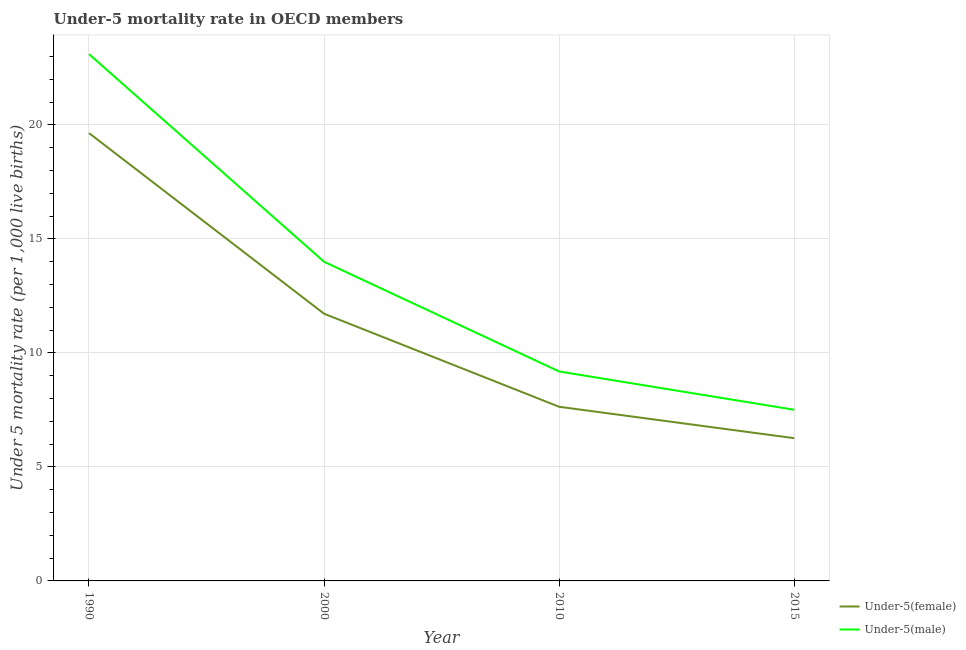Does the line corresponding to under-5 male mortality rate intersect with the line corresponding to under-5 female mortality rate?
Your response must be concise. No. What is the under-5 male mortality rate in 2010?
Your response must be concise. 9.19. Across all years, what is the maximum under-5 male mortality rate?
Ensure brevity in your answer.  23.11. Across all years, what is the minimum under-5 male mortality rate?
Give a very brief answer. 7.51. In which year was the under-5 female mortality rate maximum?
Keep it short and to the point. 1990. In which year was the under-5 male mortality rate minimum?
Your response must be concise. 2015. What is the total under-5 female mortality rate in the graph?
Provide a short and direct response. 45.26. What is the difference between the under-5 female mortality rate in 1990 and that in 2015?
Make the answer very short. 13.38. What is the difference between the under-5 male mortality rate in 2015 and the under-5 female mortality rate in 2010?
Ensure brevity in your answer.  -0.13. What is the average under-5 female mortality rate per year?
Give a very brief answer. 11.32. In the year 2010, what is the difference between the under-5 male mortality rate and under-5 female mortality rate?
Provide a succinct answer. 1.55. In how many years, is the under-5 male mortality rate greater than 7?
Provide a succinct answer. 4. What is the ratio of the under-5 male mortality rate in 2010 to that in 2015?
Keep it short and to the point. 1.22. Is the under-5 male mortality rate in 1990 less than that in 2000?
Provide a short and direct response. No. What is the difference between the highest and the second highest under-5 male mortality rate?
Give a very brief answer. 9.11. What is the difference between the highest and the lowest under-5 male mortality rate?
Offer a terse response. 15.6. Is the sum of the under-5 male mortality rate in 2010 and 2015 greater than the maximum under-5 female mortality rate across all years?
Offer a very short reply. No. Is the under-5 female mortality rate strictly less than the under-5 male mortality rate over the years?
Your response must be concise. Yes. How many lines are there?
Give a very brief answer. 2. Are the values on the major ticks of Y-axis written in scientific E-notation?
Keep it short and to the point. No. Does the graph contain any zero values?
Offer a terse response. No. Does the graph contain grids?
Offer a very short reply. Yes. How many legend labels are there?
Provide a succinct answer. 2. What is the title of the graph?
Provide a short and direct response. Under-5 mortality rate in OECD members. What is the label or title of the Y-axis?
Your answer should be very brief. Under 5 mortality rate (per 1,0 live births). What is the Under 5 mortality rate (per 1,000 live births) in Under-5(female) in 1990?
Your answer should be compact. 19.64. What is the Under 5 mortality rate (per 1,000 live births) of Under-5(male) in 1990?
Make the answer very short. 23.11. What is the Under 5 mortality rate (per 1,000 live births) in Under-5(female) in 2000?
Your response must be concise. 11.72. What is the Under 5 mortality rate (per 1,000 live births) in Under-5(male) in 2000?
Keep it short and to the point. 14. What is the Under 5 mortality rate (per 1,000 live births) of Under-5(female) in 2010?
Make the answer very short. 7.64. What is the Under 5 mortality rate (per 1,000 live births) of Under-5(male) in 2010?
Provide a short and direct response. 9.19. What is the Under 5 mortality rate (per 1,000 live births) of Under-5(female) in 2015?
Make the answer very short. 6.26. What is the Under 5 mortality rate (per 1,000 live births) in Under-5(male) in 2015?
Your response must be concise. 7.51. Across all years, what is the maximum Under 5 mortality rate (per 1,000 live births) of Under-5(female)?
Offer a terse response. 19.64. Across all years, what is the maximum Under 5 mortality rate (per 1,000 live births) of Under-5(male)?
Your answer should be very brief. 23.11. Across all years, what is the minimum Under 5 mortality rate (per 1,000 live births) in Under-5(female)?
Give a very brief answer. 6.26. Across all years, what is the minimum Under 5 mortality rate (per 1,000 live births) of Under-5(male)?
Your answer should be very brief. 7.51. What is the total Under 5 mortality rate (per 1,000 live births) of Under-5(female) in the graph?
Give a very brief answer. 45.26. What is the total Under 5 mortality rate (per 1,000 live births) of Under-5(male) in the graph?
Make the answer very short. 53.8. What is the difference between the Under 5 mortality rate (per 1,000 live births) of Under-5(female) in 1990 and that in 2000?
Give a very brief answer. 7.92. What is the difference between the Under 5 mortality rate (per 1,000 live births) of Under-5(male) in 1990 and that in 2000?
Give a very brief answer. 9.11. What is the difference between the Under 5 mortality rate (per 1,000 live births) of Under-5(female) in 1990 and that in 2010?
Ensure brevity in your answer.  12.01. What is the difference between the Under 5 mortality rate (per 1,000 live births) of Under-5(male) in 1990 and that in 2010?
Provide a succinct answer. 13.92. What is the difference between the Under 5 mortality rate (per 1,000 live births) of Under-5(female) in 1990 and that in 2015?
Make the answer very short. 13.38. What is the difference between the Under 5 mortality rate (per 1,000 live births) of Under-5(male) in 1990 and that in 2015?
Offer a very short reply. 15.6. What is the difference between the Under 5 mortality rate (per 1,000 live births) of Under-5(female) in 2000 and that in 2010?
Offer a terse response. 4.08. What is the difference between the Under 5 mortality rate (per 1,000 live births) in Under-5(male) in 2000 and that in 2010?
Give a very brief answer. 4.81. What is the difference between the Under 5 mortality rate (per 1,000 live births) of Under-5(female) in 2000 and that in 2015?
Ensure brevity in your answer.  5.46. What is the difference between the Under 5 mortality rate (per 1,000 live births) of Under-5(male) in 2000 and that in 2015?
Provide a short and direct response. 6.49. What is the difference between the Under 5 mortality rate (per 1,000 live births) in Under-5(female) in 2010 and that in 2015?
Your answer should be compact. 1.38. What is the difference between the Under 5 mortality rate (per 1,000 live births) of Under-5(male) in 2010 and that in 2015?
Your answer should be very brief. 1.68. What is the difference between the Under 5 mortality rate (per 1,000 live births) in Under-5(female) in 1990 and the Under 5 mortality rate (per 1,000 live births) in Under-5(male) in 2000?
Keep it short and to the point. 5.65. What is the difference between the Under 5 mortality rate (per 1,000 live births) of Under-5(female) in 1990 and the Under 5 mortality rate (per 1,000 live births) of Under-5(male) in 2010?
Make the answer very short. 10.46. What is the difference between the Under 5 mortality rate (per 1,000 live births) of Under-5(female) in 1990 and the Under 5 mortality rate (per 1,000 live births) of Under-5(male) in 2015?
Provide a succinct answer. 12.14. What is the difference between the Under 5 mortality rate (per 1,000 live births) in Under-5(female) in 2000 and the Under 5 mortality rate (per 1,000 live births) in Under-5(male) in 2010?
Keep it short and to the point. 2.53. What is the difference between the Under 5 mortality rate (per 1,000 live births) in Under-5(female) in 2000 and the Under 5 mortality rate (per 1,000 live births) in Under-5(male) in 2015?
Your response must be concise. 4.21. What is the difference between the Under 5 mortality rate (per 1,000 live births) in Under-5(female) in 2010 and the Under 5 mortality rate (per 1,000 live births) in Under-5(male) in 2015?
Your answer should be very brief. 0.13. What is the average Under 5 mortality rate (per 1,000 live births) in Under-5(female) per year?
Offer a very short reply. 11.32. What is the average Under 5 mortality rate (per 1,000 live births) in Under-5(male) per year?
Offer a terse response. 13.45. In the year 1990, what is the difference between the Under 5 mortality rate (per 1,000 live births) in Under-5(female) and Under 5 mortality rate (per 1,000 live births) in Under-5(male)?
Offer a terse response. -3.46. In the year 2000, what is the difference between the Under 5 mortality rate (per 1,000 live births) of Under-5(female) and Under 5 mortality rate (per 1,000 live births) of Under-5(male)?
Provide a short and direct response. -2.28. In the year 2010, what is the difference between the Under 5 mortality rate (per 1,000 live births) in Under-5(female) and Under 5 mortality rate (per 1,000 live births) in Under-5(male)?
Provide a short and direct response. -1.55. In the year 2015, what is the difference between the Under 5 mortality rate (per 1,000 live births) of Under-5(female) and Under 5 mortality rate (per 1,000 live births) of Under-5(male)?
Make the answer very short. -1.25. What is the ratio of the Under 5 mortality rate (per 1,000 live births) of Under-5(female) in 1990 to that in 2000?
Your response must be concise. 1.68. What is the ratio of the Under 5 mortality rate (per 1,000 live births) in Under-5(male) in 1990 to that in 2000?
Provide a short and direct response. 1.65. What is the ratio of the Under 5 mortality rate (per 1,000 live births) of Under-5(female) in 1990 to that in 2010?
Your answer should be very brief. 2.57. What is the ratio of the Under 5 mortality rate (per 1,000 live births) of Under-5(male) in 1990 to that in 2010?
Provide a short and direct response. 2.52. What is the ratio of the Under 5 mortality rate (per 1,000 live births) in Under-5(female) in 1990 to that in 2015?
Make the answer very short. 3.14. What is the ratio of the Under 5 mortality rate (per 1,000 live births) in Under-5(male) in 1990 to that in 2015?
Your answer should be very brief. 3.08. What is the ratio of the Under 5 mortality rate (per 1,000 live births) in Under-5(female) in 2000 to that in 2010?
Make the answer very short. 1.53. What is the ratio of the Under 5 mortality rate (per 1,000 live births) in Under-5(male) in 2000 to that in 2010?
Keep it short and to the point. 1.52. What is the ratio of the Under 5 mortality rate (per 1,000 live births) of Under-5(female) in 2000 to that in 2015?
Your answer should be compact. 1.87. What is the ratio of the Under 5 mortality rate (per 1,000 live births) of Under-5(male) in 2000 to that in 2015?
Offer a very short reply. 1.86. What is the ratio of the Under 5 mortality rate (per 1,000 live births) in Under-5(female) in 2010 to that in 2015?
Provide a succinct answer. 1.22. What is the ratio of the Under 5 mortality rate (per 1,000 live births) of Under-5(male) in 2010 to that in 2015?
Provide a succinct answer. 1.22. What is the difference between the highest and the second highest Under 5 mortality rate (per 1,000 live births) of Under-5(female)?
Your response must be concise. 7.92. What is the difference between the highest and the second highest Under 5 mortality rate (per 1,000 live births) of Under-5(male)?
Offer a very short reply. 9.11. What is the difference between the highest and the lowest Under 5 mortality rate (per 1,000 live births) in Under-5(female)?
Your answer should be very brief. 13.38. What is the difference between the highest and the lowest Under 5 mortality rate (per 1,000 live births) of Under-5(male)?
Your answer should be compact. 15.6. 